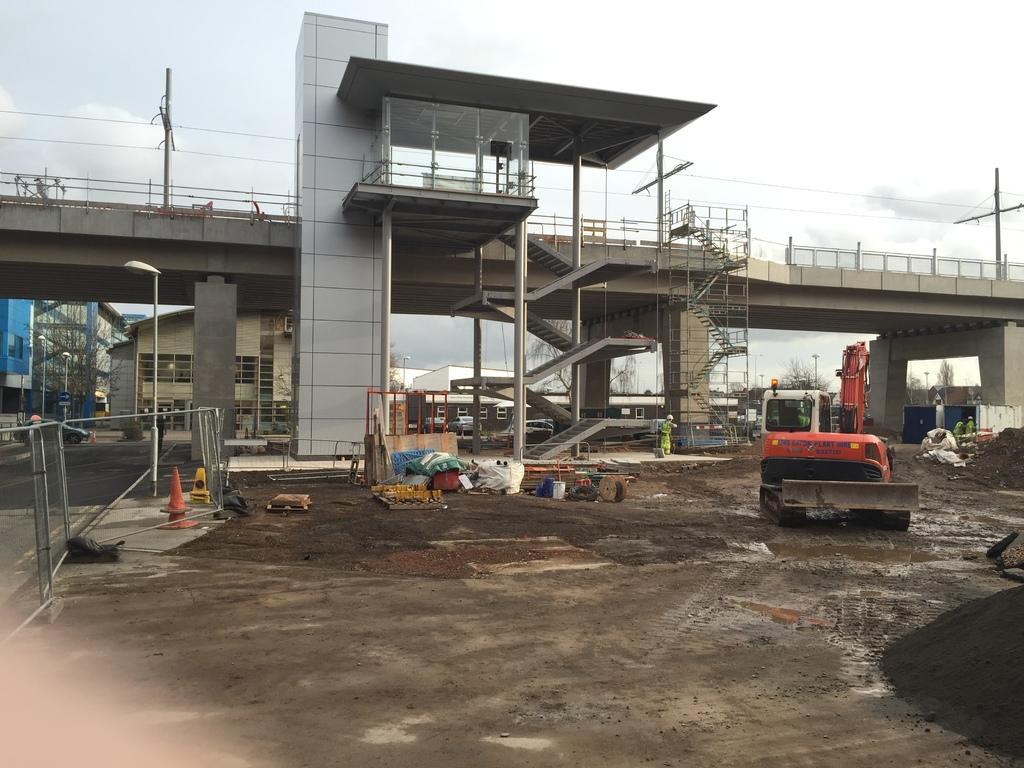Please provide a concise description of this image. In this picture we can see bridge and steps to the bridge and in front of the bridge we can see some vehicles, land, traffic cones, fence with metal, pole, light attached to it and in the background we can see buildings and hear the person standing at the steps. 